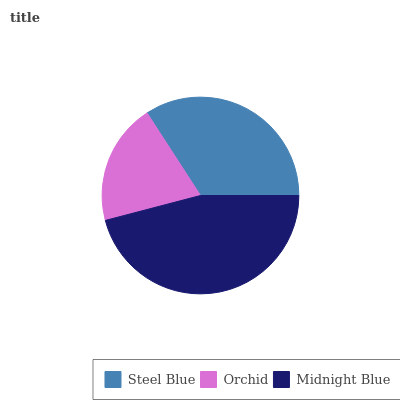Is Orchid the minimum?
Answer yes or no. Yes. Is Midnight Blue the maximum?
Answer yes or no. Yes. Is Midnight Blue the minimum?
Answer yes or no. No. Is Orchid the maximum?
Answer yes or no. No. Is Midnight Blue greater than Orchid?
Answer yes or no. Yes. Is Orchid less than Midnight Blue?
Answer yes or no. Yes. Is Orchid greater than Midnight Blue?
Answer yes or no. No. Is Midnight Blue less than Orchid?
Answer yes or no. No. Is Steel Blue the high median?
Answer yes or no. Yes. Is Steel Blue the low median?
Answer yes or no. Yes. Is Orchid the high median?
Answer yes or no. No. Is Midnight Blue the low median?
Answer yes or no. No. 